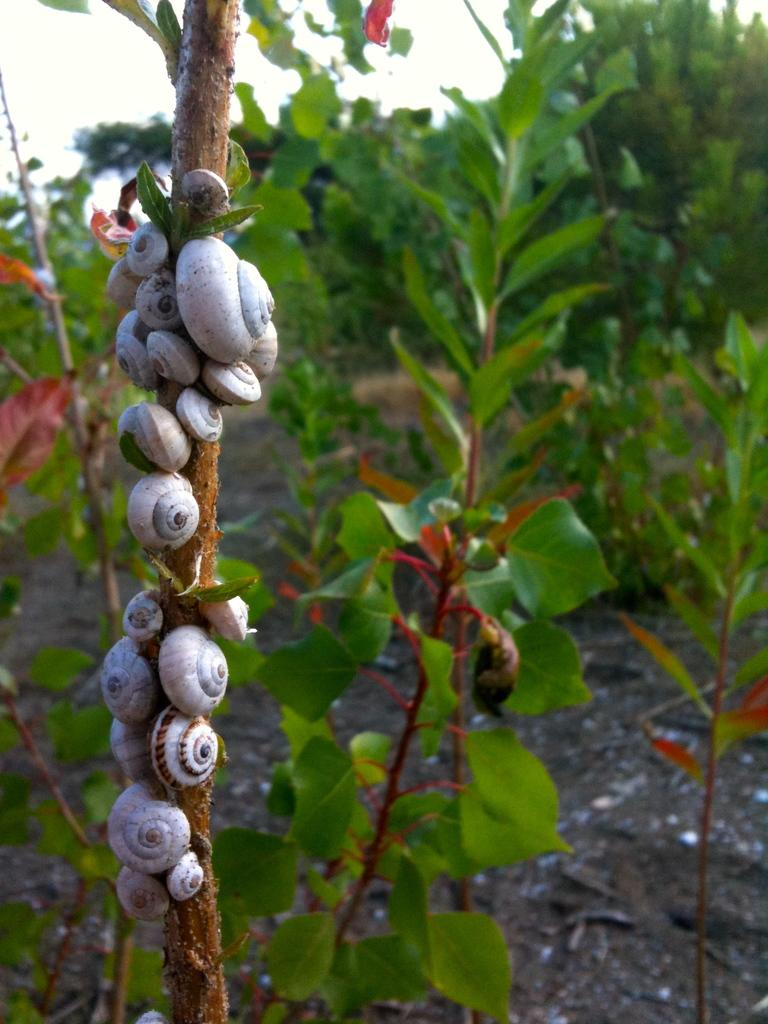What is located on the left side of the image? There is a stem on the left side of the image. What is attached to the stem? There are shells on the stem. What can be seen in the background of the image? There are other plants in the background of the image. What type of horse can be seen in the image? There is no horse present in the image; it features a stem with shells and other plants in the background. What invention is being used to light the shells in the image? There is no invention or lighting involved in the image; it simply shows a stem with shells and other plants in the background. 